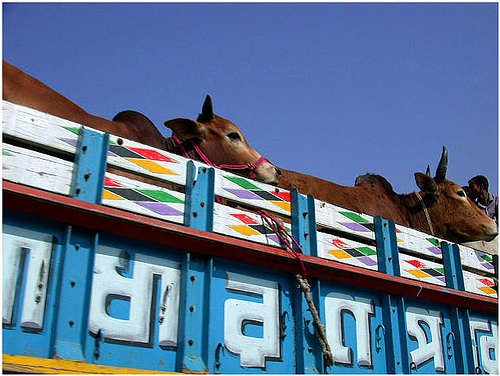Describe the objects in this image and their specific colors. I can see cow in white, maroon, black, and brown tones, cow in white, maroon, black, and gray tones, people in white, black, gray, maroon, and darkgray tones, and people in white, black, maroon, and purple tones in this image. 